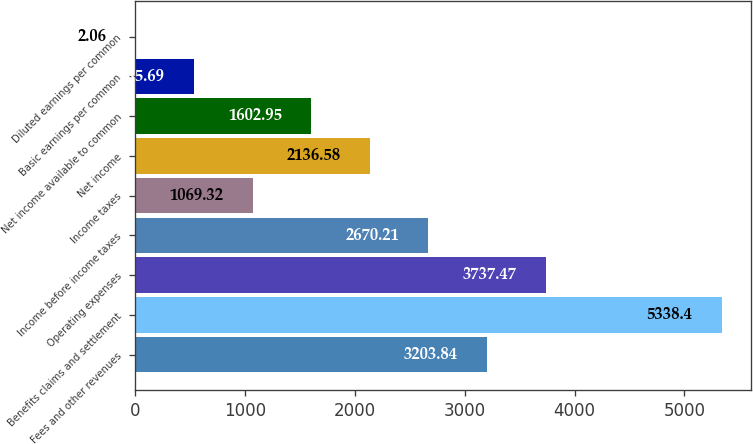<chart> <loc_0><loc_0><loc_500><loc_500><bar_chart><fcel>Fees and other revenues<fcel>Benefits claims and settlement<fcel>Operating expenses<fcel>Income before income taxes<fcel>Income taxes<fcel>Net income<fcel>Net income available to common<fcel>Basic earnings per common<fcel>Diluted earnings per common<nl><fcel>3203.84<fcel>5338.4<fcel>3737.47<fcel>2670.21<fcel>1069.32<fcel>2136.58<fcel>1602.95<fcel>535.69<fcel>2.06<nl></chart> 